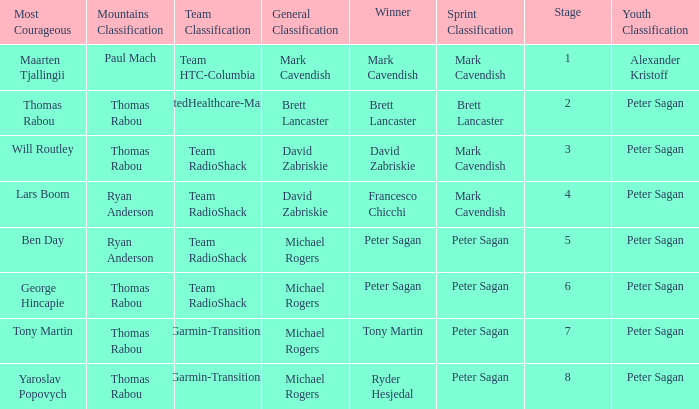When Mark Cavendish wins sprint classification and Maarten Tjallingii wins most courageous, who wins youth classification? Alexander Kristoff. 